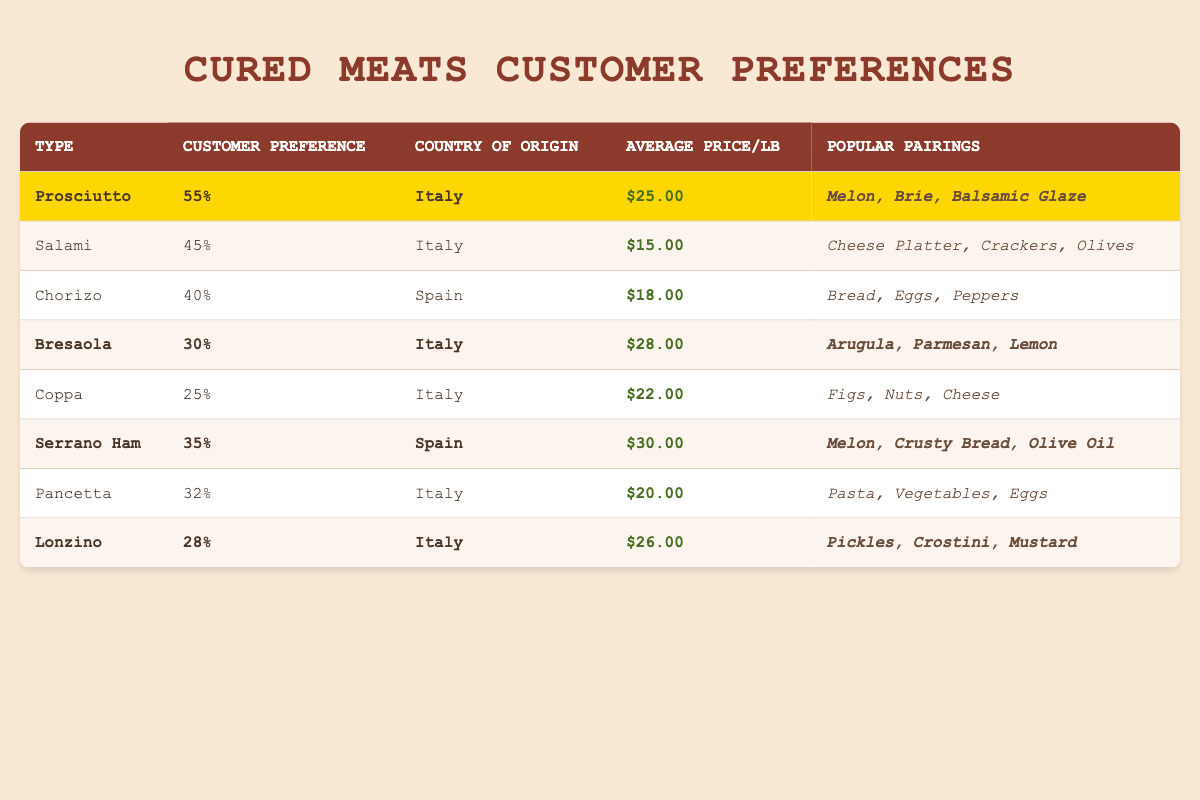What is the customer preference percentage for Prosciutto? The table indicates that the customer preference percentage for Prosciutto is listed directly under the "Customer Preference" column, which shows 55%.
Answer: 55% Which cured meat has the highest average price per pound? Looking at the "Average Price/lb" column, I can see that Serrano Ham has the highest value at $30.00 per pound.
Answer: $30.00 Is Bresaola more popular than Chorizo based on customer preference percentage? Bresaola has a customer preference of 30%, while Chorizo has 40%, meaning Chorizo is more popular.
Answer: No Which types of cured meat are highlighted in the table? The highlighted rows in the table represent Prosciutto, Bresaola, Serrano Ham, and Lonzino, as indicated by the designated background color for these rows.
Answer: Prosciutto, Bresaola, Serrano Ham, Lonzino What is the average customer preference percentage of all the cured meats listed in the table? I first sum all the customer preference percentages: 55 + 45 + 40 + 30 + 25 + 35 + 32 + 28 = 290. Then, I divide by the number of meats (8), which results in 36.25.
Answer: 36.25 How does the popularity of Italian cured meats compare to Spanish cured meats based on customer preference? I examine the totals for Italian meats: 55 + 45 + 30 + 25 + 32 + 28 = 215, while for Spanish meats: 40 + 35 = 75. Italian cured meats are significantly more popular.
Answer: Italian cured meats are more popular What are the popular pairings for the most preferred cured meat? Prosciutto has the highest preference at 55%, and its popular pairings are listed as Melon, Brie, and Balsamic Glaze.
Answer: Melon, Brie, Balsamic Glaze Is there a correlation between customer preference percentage and average price per pound among the cured meats? Examining the data, there is not a clear correlation; for example, Bresaola is quite expensive at $28.00 but has a lower preference at 30%, while Salami is cheaper at $15.00 yet preferred at 45%.
Answer: No clear correlation 